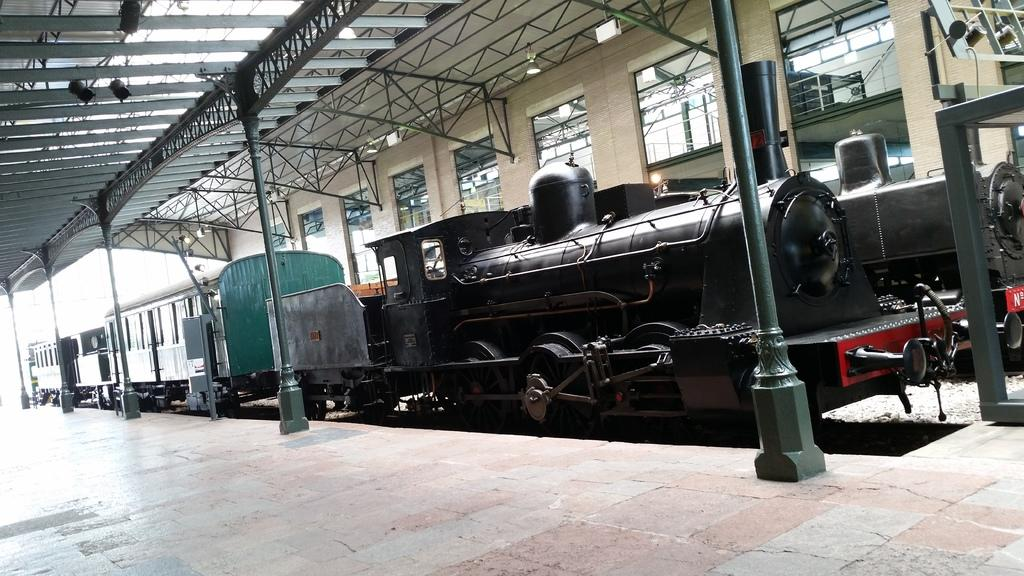What is the main subject of the image? There is a train in the image. What is the train's position in relation to the track? The train is on a track. What architectural features can be seen in the image? There are pillars visible in the image. What can be seen through the windows in the image? The image may have been taken on a platform. Can you tell me how many tomatoes are on the rooftop in the image? There are no tomatoes present on the rooftop in the image. What type of sound can be heard coming from the train in the image? The image is static, so no sound can be heard from the train. 